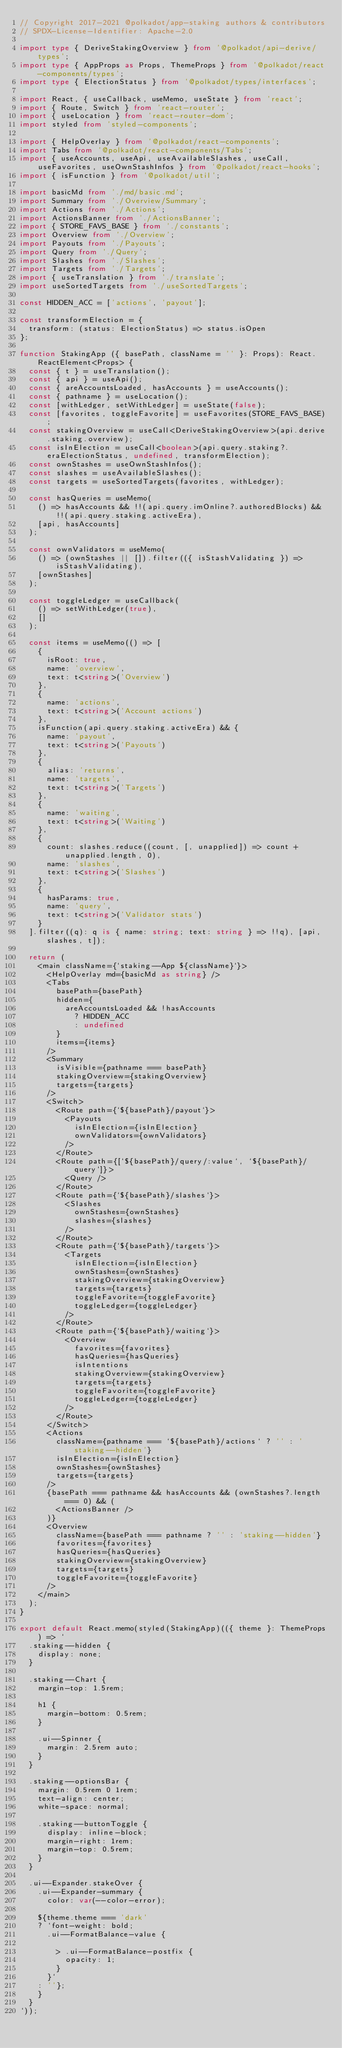<code> <loc_0><loc_0><loc_500><loc_500><_TypeScript_>// Copyright 2017-2021 @polkadot/app-staking authors & contributors
// SPDX-License-Identifier: Apache-2.0

import type { DeriveStakingOverview } from '@polkadot/api-derive/types';
import type { AppProps as Props, ThemeProps } from '@polkadot/react-components/types';
import type { ElectionStatus } from '@polkadot/types/interfaces';

import React, { useCallback, useMemo, useState } from 'react';
import { Route, Switch } from 'react-router';
import { useLocation } from 'react-router-dom';
import styled from 'styled-components';

import { HelpOverlay } from '@polkadot/react-components';
import Tabs from '@polkadot/react-components/Tabs';
import { useAccounts, useApi, useAvailableSlashes, useCall, useFavorites, useOwnStashInfos } from '@polkadot/react-hooks';
import { isFunction } from '@polkadot/util';

import basicMd from './md/basic.md';
import Summary from './Overview/Summary';
import Actions from './Actions';
import ActionsBanner from './ActionsBanner';
import { STORE_FAVS_BASE } from './constants';
import Overview from './Overview';
import Payouts from './Payouts';
import Query from './Query';
import Slashes from './Slashes';
import Targets from './Targets';
import { useTranslation } from './translate';
import useSortedTargets from './useSortedTargets';

const HIDDEN_ACC = ['actions', 'payout'];

const transformElection = {
  transform: (status: ElectionStatus) => status.isOpen
};

function StakingApp ({ basePath, className = '' }: Props): React.ReactElement<Props> {
  const { t } = useTranslation();
  const { api } = useApi();
  const { areAccountsLoaded, hasAccounts } = useAccounts();
  const { pathname } = useLocation();
  const [withLedger, setWithLedger] = useState(false);
  const [favorites, toggleFavorite] = useFavorites(STORE_FAVS_BASE);
  const stakingOverview = useCall<DeriveStakingOverview>(api.derive.staking.overview);
  const isInElection = useCall<boolean>(api.query.staking?.eraElectionStatus, undefined, transformElection);
  const ownStashes = useOwnStashInfos();
  const slashes = useAvailableSlashes();
  const targets = useSortedTargets(favorites, withLedger);

  const hasQueries = useMemo(
    () => hasAccounts && !!(api.query.imOnline?.authoredBlocks) && !!(api.query.staking.activeEra),
    [api, hasAccounts]
  );

  const ownValidators = useMemo(
    () => (ownStashes || []).filter(({ isStashValidating }) => isStashValidating),
    [ownStashes]
  );

  const toggleLedger = useCallback(
    () => setWithLedger(true),
    []
  );

  const items = useMemo(() => [
    {
      isRoot: true,
      name: 'overview',
      text: t<string>('Overview')
    },
    {
      name: 'actions',
      text: t<string>('Account actions')
    },
    isFunction(api.query.staking.activeEra) && {
      name: 'payout',
      text: t<string>('Payouts')
    },
    {
      alias: 'returns',
      name: 'targets',
      text: t<string>('Targets')
    },
    {
      name: 'waiting',
      text: t<string>('Waiting')
    },
    {
      count: slashes.reduce((count, [, unapplied]) => count + unapplied.length, 0),
      name: 'slashes',
      text: t<string>('Slashes')
    },
    {
      hasParams: true,
      name: 'query',
      text: t<string>('Validator stats')
    }
  ].filter((q): q is { name: string; text: string } => !!q), [api, slashes, t]);

  return (
    <main className={`staking--App ${className}`}>
      <HelpOverlay md={basicMd as string} />
      <Tabs
        basePath={basePath}
        hidden={
          areAccountsLoaded && !hasAccounts
            ? HIDDEN_ACC
            : undefined
        }
        items={items}
      />
      <Summary
        isVisible={pathname === basePath}
        stakingOverview={stakingOverview}
        targets={targets}
      />
      <Switch>
        <Route path={`${basePath}/payout`}>
          <Payouts
            isInElection={isInElection}
            ownValidators={ownValidators}
          />
        </Route>
        <Route path={[`${basePath}/query/:value`, `${basePath}/query`]}>
          <Query />
        </Route>
        <Route path={`${basePath}/slashes`}>
          <Slashes
            ownStashes={ownStashes}
            slashes={slashes}
          />
        </Route>
        <Route path={`${basePath}/targets`}>
          <Targets
            isInElection={isInElection}
            ownStashes={ownStashes}
            stakingOverview={stakingOverview}
            targets={targets}
            toggleFavorite={toggleFavorite}
            toggleLedger={toggleLedger}
          />
        </Route>
        <Route path={`${basePath}/waiting`}>
          <Overview
            favorites={favorites}
            hasQueries={hasQueries}
            isIntentions
            stakingOverview={stakingOverview}
            targets={targets}
            toggleFavorite={toggleFavorite}
            toggleLedger={toggleLedger}
          />
        </Route>
      </Switch>
      <Actions
        className={pathname === `${basePath}/actions` ? '' : 'staking--hidden'}
        isInElection={isInElection}
        ownStashes={ownStashes}
        targets={targets}
      />
      {basePath === pathname && hasAccounts && (ownStashes?.length === 0) && (
        <ActionsBanner />
      )}
      <Overview
        className={basePath === pathname ? '' : 'staking--hidden'}
        favorites={favorites}
        hasQueries={hasQueries}
        stakingOverview={stakingOverview}
        targets={targets}
        toggleFavorite={toggleFavorite}
      />
    </main>
  );
}

export default React.memo(styled(StakingApp)(({ theme }: ThemeProps) => `
  .staking--hidden {
    display: none;
  }

  .staking--Chart {
    margin-top: 1.5rem;

    h1 {
      margin-bottom: 0.5rem;
    }

    .ui--Spinner {
      margin: 2.5rem auto;
    }
  }

  .staking--optionsBar {
    margin: 0.5rem 0 1rem;
    text-align: center;
    white-space: normal;

    .staking--buttonToggle {
      display: inline-block;
      margin-right: 1rem;
      margin-top: 0.5rem;
    }
  }

  .ui--Expander.stakeOver {
    .ui--Expander-summary {
      color: var(--color-error);

    ${theme.theme === 'dark'
    ? `font-weight: bold;
      .ui--FormatBalance-value {

        > .ui--FormatBalance-postfix {
          opacity: 1;
        }
      }`
    : ''};
    }
  }
`));
</code> 